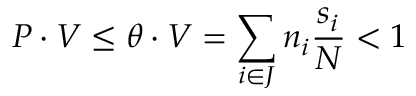<formula> <loc_0><loc_0><loc_500><loc_500>P \cdot V \leq \theta \cdot V = \sum _ { i \in J } n _ { i } \frac { s _ { i } } { N } < 1</formula> 